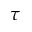Convert formula to latex. <formula><loc_0><loc_0><loc_500><loc_500>\tau</formula> 